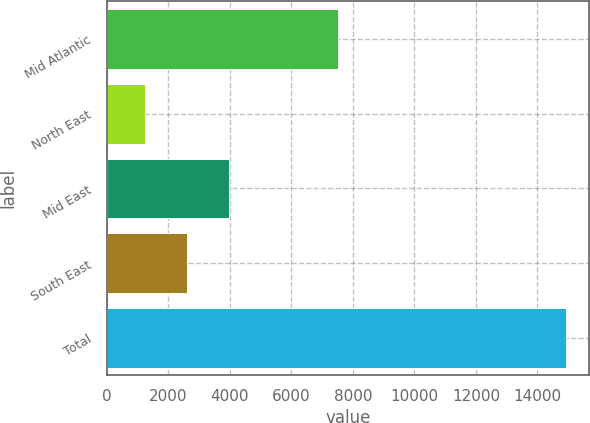Convert chart. <chart><loc_0><loc_0><loc_500><loc_500><bar_chart><fcel>Mid Atlantic<fcel>North East<fcel>Mid East<fcel>South East<fcel>Total<nl><fcel>7512<fcel>1246<fcel>3982.4<fcel>2614.2<fcel>14928<nl></chart> 